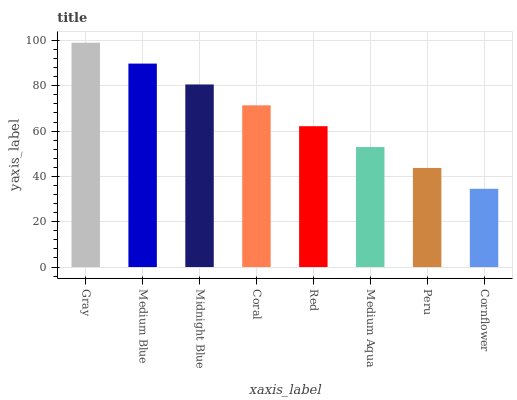Is Cornflower the minimum?
Answer yes or no. Yes. Is Gray the maximum?
Answer yes or no. Yes. Is Medium Blue the minimum?
Answer yes or no. No. Is Medium Blue the maximum?
Answer yes or no. No. Is Gray greater than Medium Blue?
Answer yes or no. Yes. Is Medium Blue less than Gray?
Answer yes or no. Yes. Is Medium Blue greater than Gray?
Answer yes or no. No. Is Gray less than Medium Blue?
Answer yes or no. No. Is Coral the high median?
Answer yes or no. Yes. Is Red the low median?
Answer yes or no. Yes. Is Gray the high median?
Answer yes or no. No. Is Midnight Blue the low median?
Answer yes or no. No. 